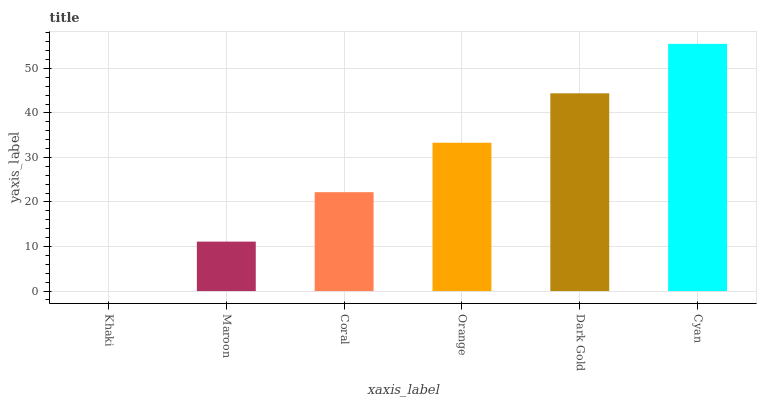Is Khaki the minimum?
Answer yes or no. Yes. Is Cyan the maximum?
Answer yes or no. Yes. Is Maroon the minimum?
Answer yes or no. No. Is Maroon the maximum?
Answer yes or no. No. Is Maroon greater than Khaki?
Answer yes or no. Yes. Is Khaki less than Maroon?
Answer yes or no. Yes. Is Khaki greater than Maroon?
Answer yes or no. No. Is Maroon less than Khaki?
Answer yes or no. No. Is Orange the high median?
Answer yes or no. Yes. Is Coral the low median?
Answer yes or no. Yes. Is Dark Gold the high median?
Answer yes or no. No. Is Dark Gold the low median?
Answer yes or no. No. 